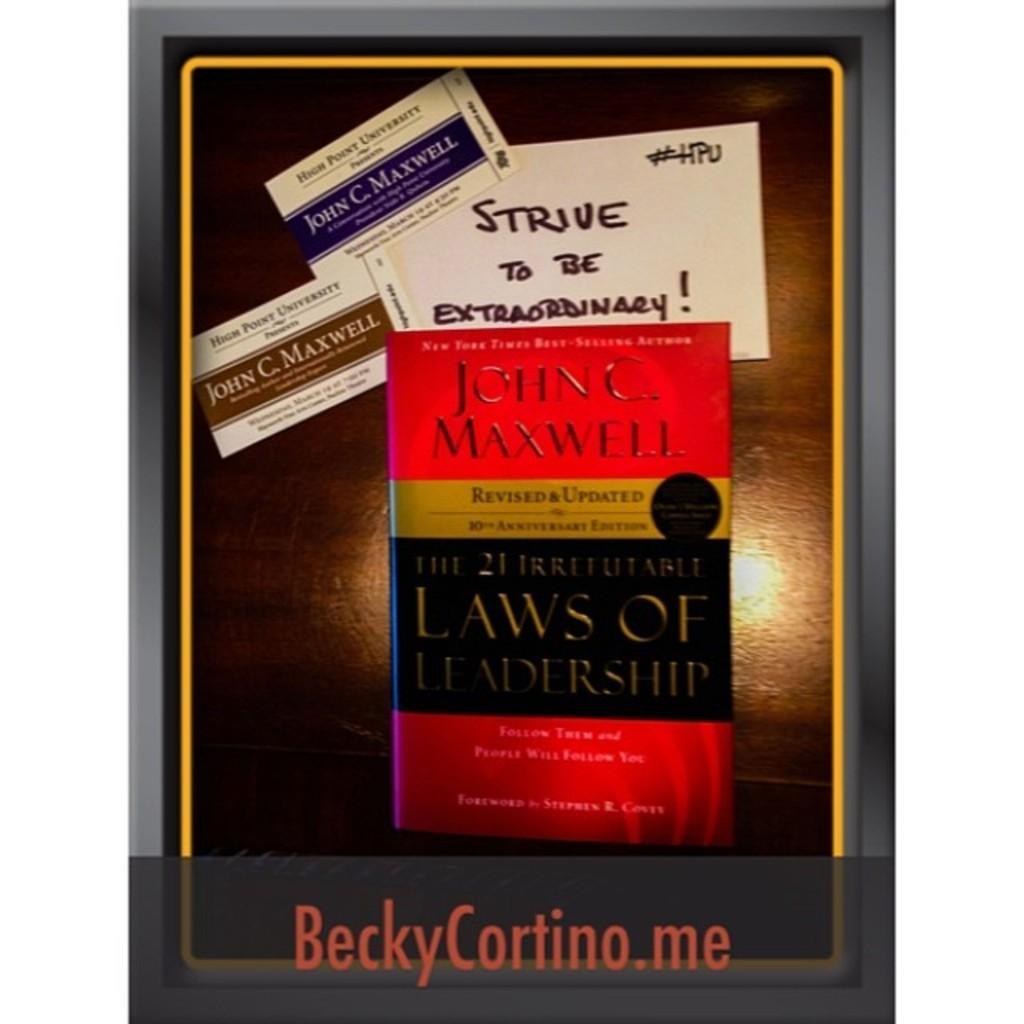How would you summarize this image in a sentence or two? In this image there is a poster having a book and few cards pictures are on it. Bottom of image there is some text. Cards and books are having some text on it. 